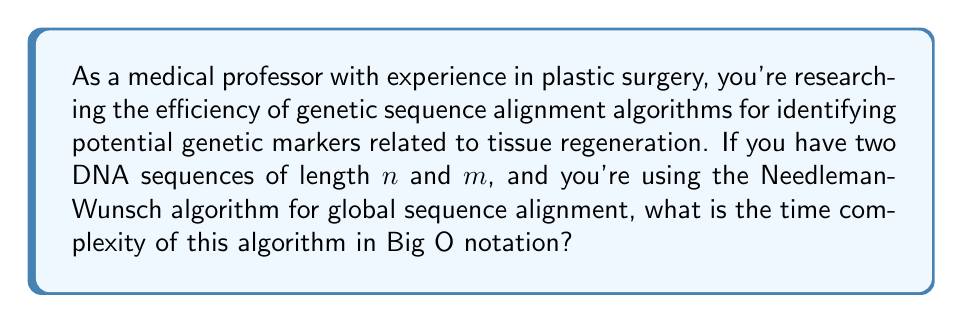Show me your answer to this math problem. To understand the time complexity of the Needleman-Wunsch algorithm, let's break down its steps:

1. The algorithm uses dynamic programming to build a scoring matrix.

2. The matrix has dimensions $(n+1) \times (m+1)$, where $n$ and $m$ are the lengths of the two sequences being aligned.

3. For each cell in the matrix, the algorithm performs a constant number of operations:
   - Calculating three possible scores (match/mismatch, insertion, deletion)
   - Choosing the maximum of these scores
   - Storing the result

4. The algorithm needs to fill in every cell of the matrix.

Therefore, the total number of operations is proportional to the number of cells in the matrix:

$$ \text{Number of operations} \propto (n+1) \times (m+1) $$

In Big O notation, we typically express complexity in terms of the largest input size. If we assume $n \geq m$, then:

$$ O((n+1) \times (m+1)) = O(nm) $$

The addition of 1 to $n$ and $m$ doesn't affect the asymptotic complexity, so we can simplify it to $O(nm)$.

This quadratic time complexity means that as the length of the sequences increases, the computation time increases quadratically. For example, doubling the length of both sequences would increase the computation time by approximately a factor of 4.
Answer: $O(nm)$ 